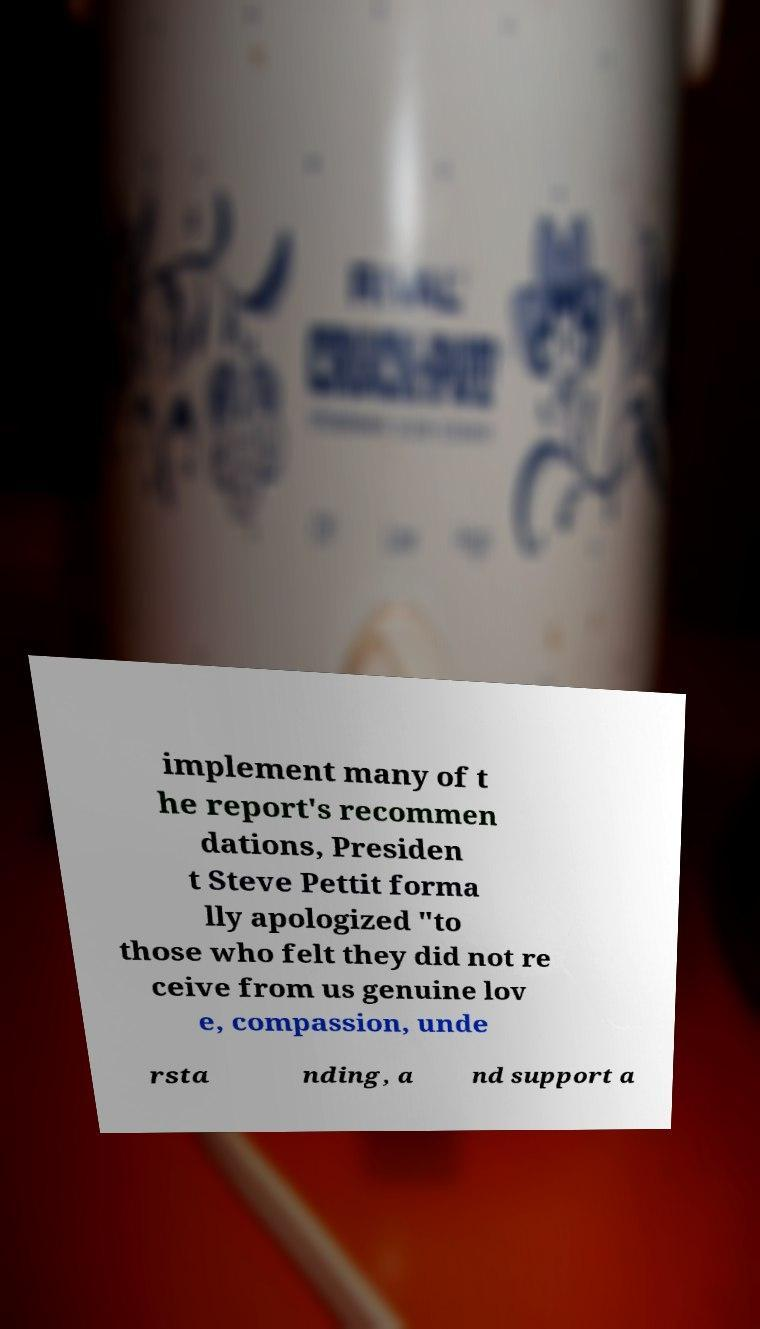What messages or text are displayed in this image? I need them in a readable, typed format. implement many of t he report's recommen dations, Presiden t Steve Pettit forma lly apologized "to those who felt they did not re ceive from us genuine lov e, compassion, unde rsta nding, a nd support a 